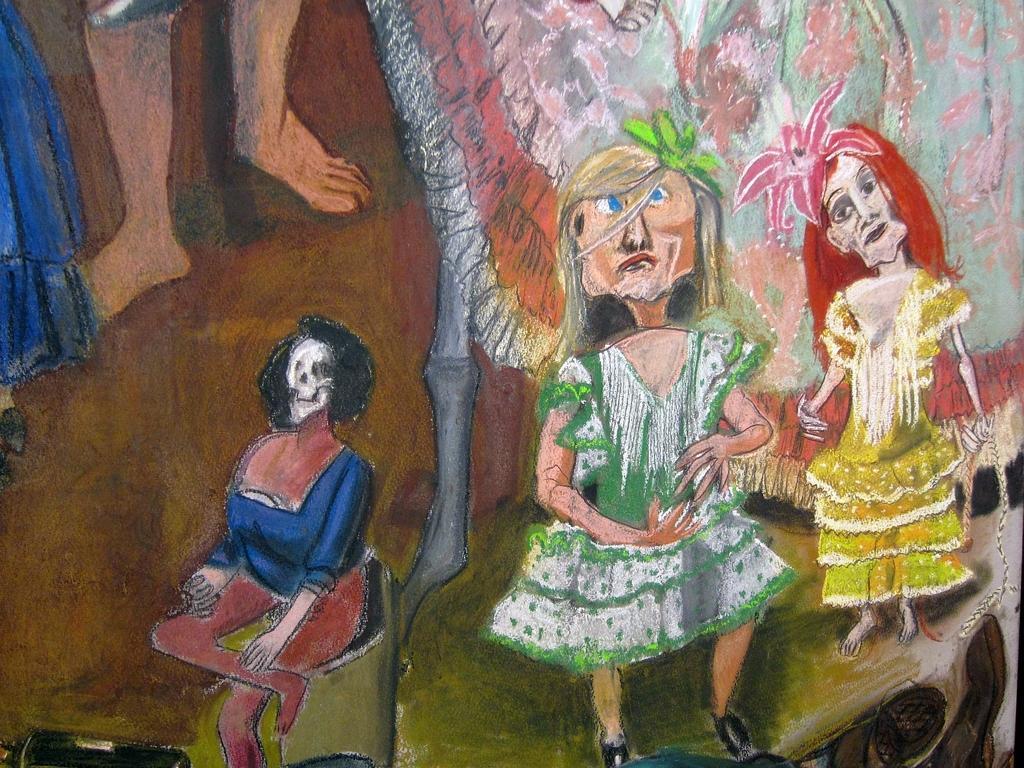In one or two sentences, can you explain what this image depicts? In the center of the image we can see some painting, in which we can see two persons are standing and one person is sitting. And we can see human legs and a few other objects. 